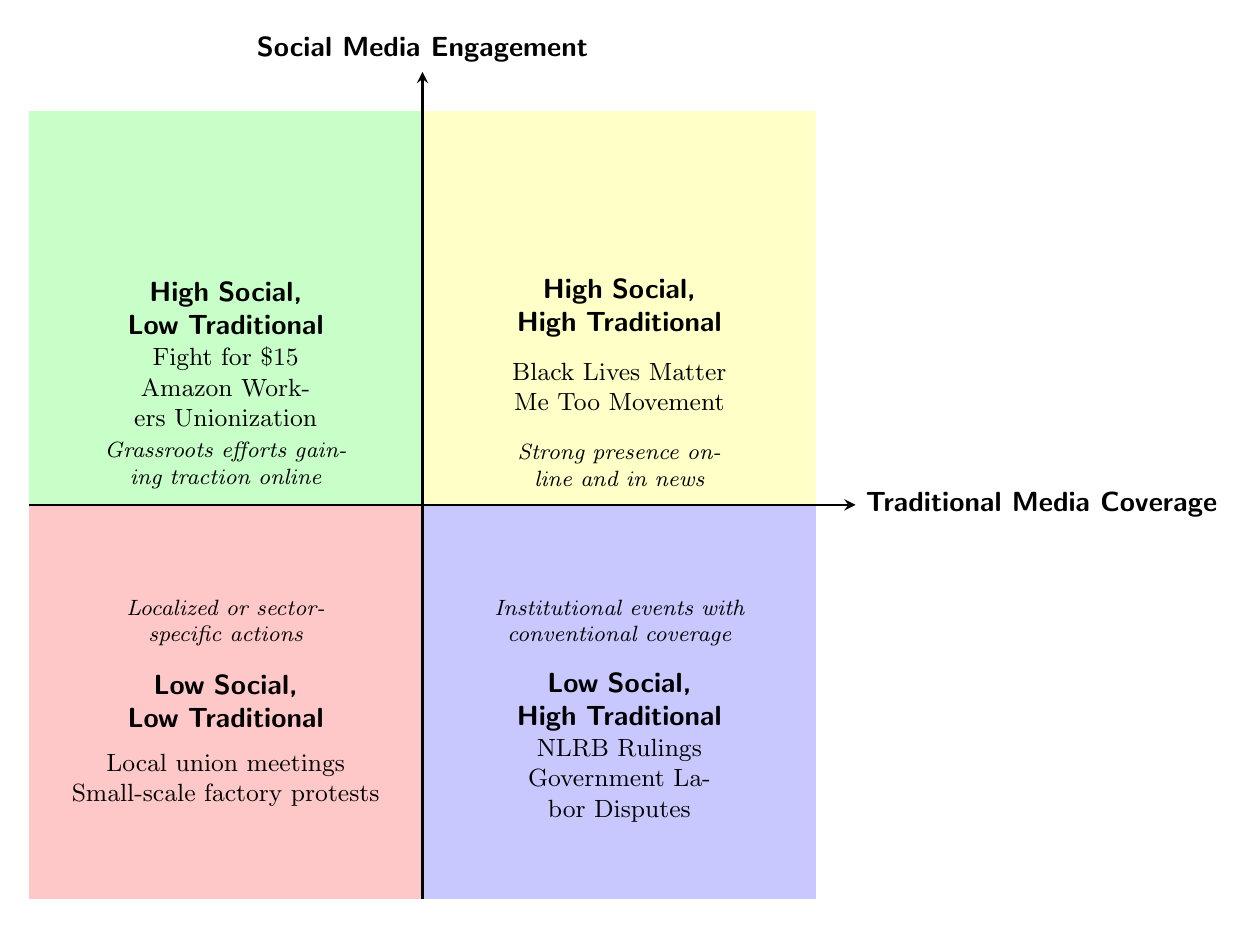What examples are in the quadrant with high social media engagement and high traditional media coverage? The quadrant labeled "High Social, High Traditional" contains examples of the Black Lives Matter Movement and the Me Too Movement.
Answer: Black Lives Matter Movement, Me Too Movement How many examples are given in the quadrant with low social media engagement and low traditional media coverage? The quadrant labeled "Low Social, Low Traditional" has two examples: local union meetings and small-scale factory protests, thus there are two examples in this quadrant.
Answer: 2 What is the general description of campaigns in the quadrant with high social media engagement and low traditional media coverage? In the quadrant labeled "High Social, Low Traditional," the description states that these are grassroots efforts gaining traction online but having less coverage by traditional news.
Answer: Grassroots efforts gaining traction online Which quadrant includes government labor disputes? The example of government labor disputes is mentioned in the quadrant marked "Low Social, High Traditional," which represents institutional events with significant but conventional media coverage.
Answer: Low Social, High Traditional What does the quadrant labeled "Low Social, Low Traditional" specifically describe? This quadrant describes localized or sector-specific actions with minimal coverage in any media, indicating a low presence in both social and traditional media.
Answer: Localized or sector-specific actions What is the significance of the example of the Fight for $15? The Fight for $15 is placed in the "High Social, Low Traditional" quadrant, suggesting it is a grassroots effort that is gaining more visibility and engagement on social media, despite lesser traditional media coverage.
Answer: High Social, Low Traditional What color represents the quadrant with low traditional media coverage? The quadrant with low traditional media coverage is represented in color, specifically in the lower-left corner of the diagram which is shown in a yellow shade, indicating its classification.
Answer: Yellow Which quadrant has a strong presence in both social and traditional media? The quadrant known for having both high social media engagement and high traditional media coverage is labeled "High Social, High Traditional."
Answer: High Social, High Traditional 